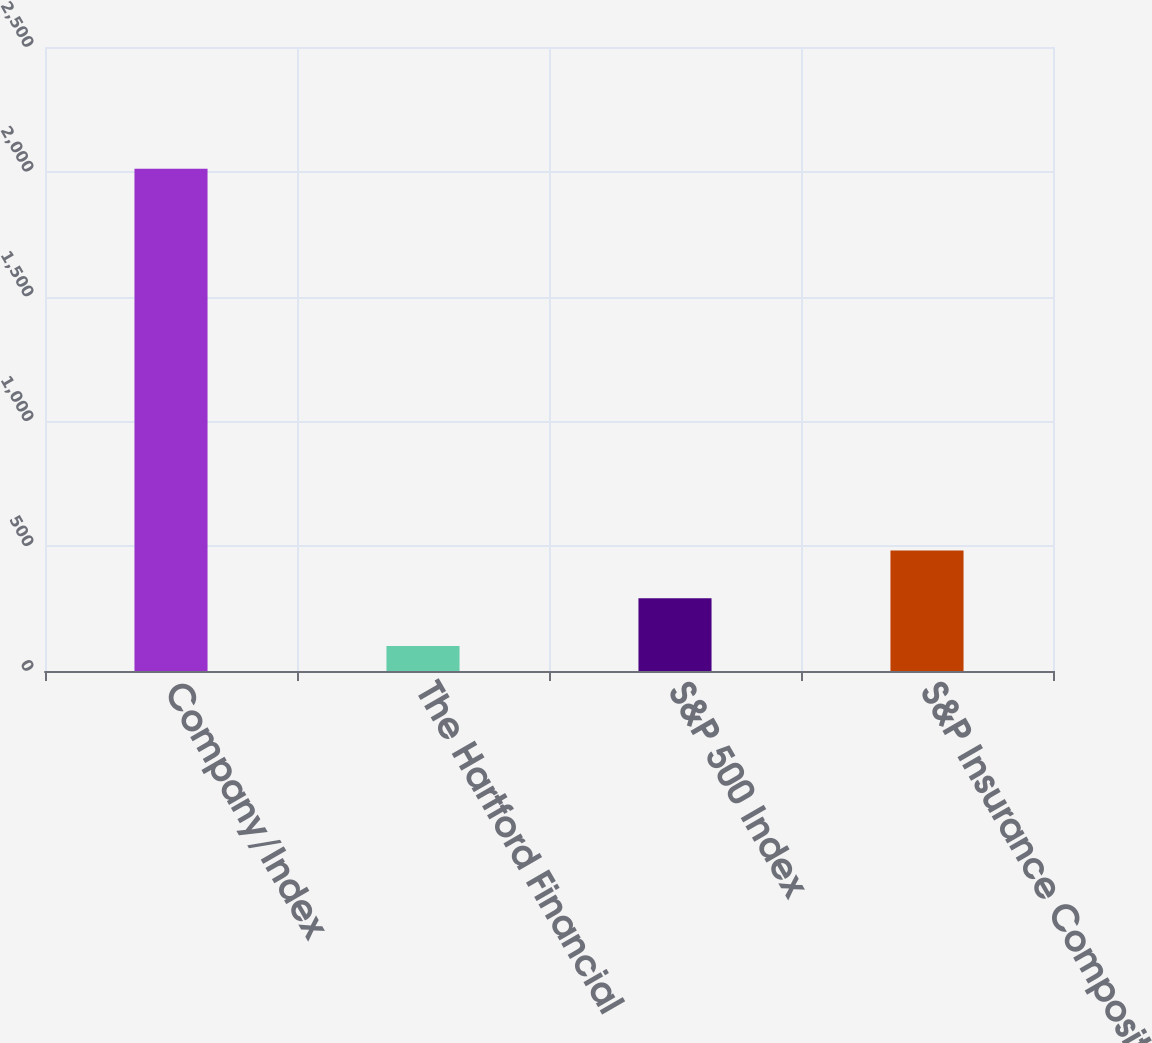Convert chart. <chart><loc_0><loc_0><loc_500><loc_500><bar_chart><fcel>Company/Index<fcel>The Hartford Financial<fcel>S&P 500 Index<fcel>S&P Insurance Composite Index<nl><fcel>2012<fcel>100<fcel>291.2<fcel>482.4<nl></chart> 